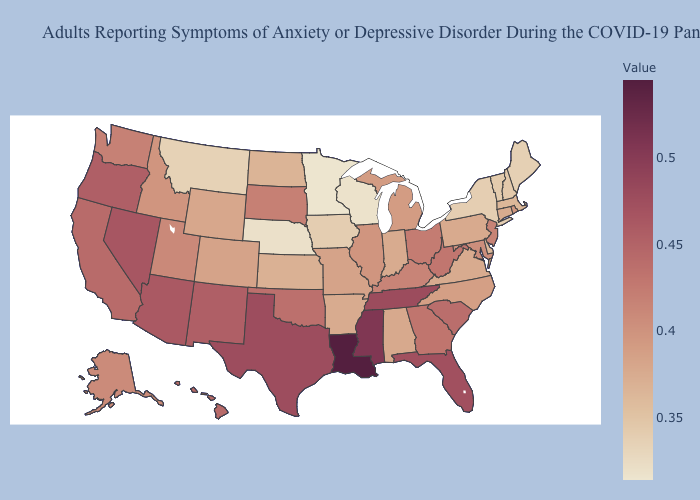Does Connecticut have the lowest value in the USA?
Quick response, please. No. Among the states that border South Dakota , does Iowa have the highest value?
Be succinct. No. Among the states that border California , does Nevada have the lowest value?
Write a very short answer. No. Which states have the lowest value in the USA?
Quick response, please. Minnesota. Which states have the lowest value in the West?
Concise answer only. Montana. 